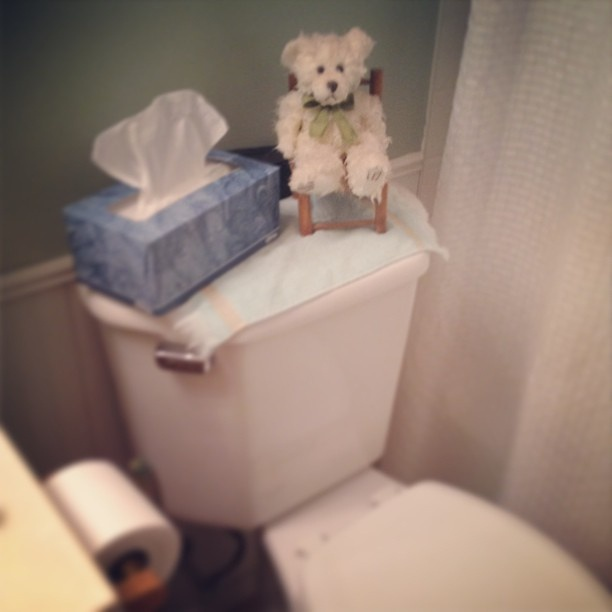Describe the objects in this image and their specific colors. I can see toilet in black, tan, darkgray, and gray tones and teddy bear in black, tan, and gray tones in this image. 